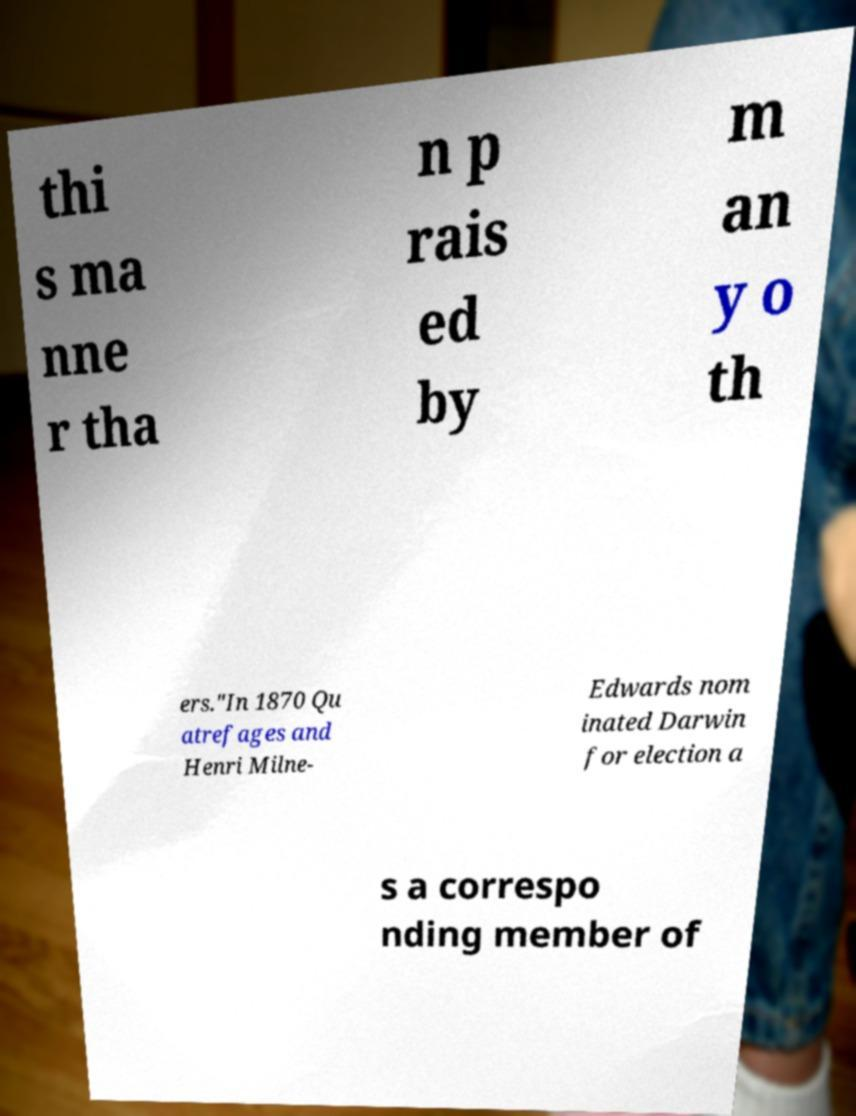Please identify and transcribe the text found in this image. thi s ma nne r tha n p rais ed by m an y o th ers."In 1870 Qu atrefages and Henri Milne- Edwards nom inated Darwin for election a s a correspo nding member of 